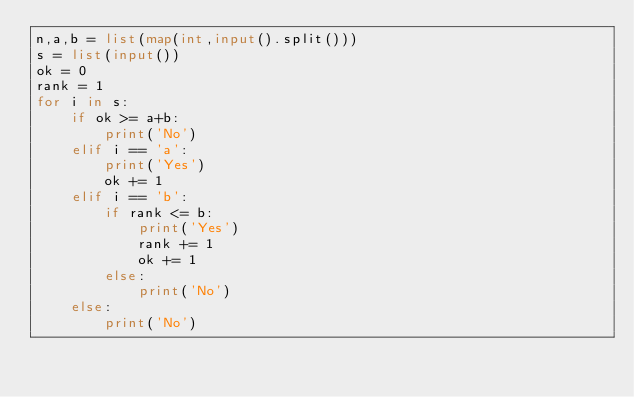Convert code to text. <code><loc_0><loc_0><loc_500><loc_500><_Python_>n,a,b = list(map(int,input().split()))
s = list(input())
ok = 0
rank = 1
for i in s:
    if ok >= a+b:
        print('No')
    elif i == 'a':
        print('Yes')
        ok += 1
    elif i == 'b':
        if rank <= b:
            print('Yes')
            rank += 1
            ok += 1
        else:
            print('No')
    else:
        print('No')</code> 